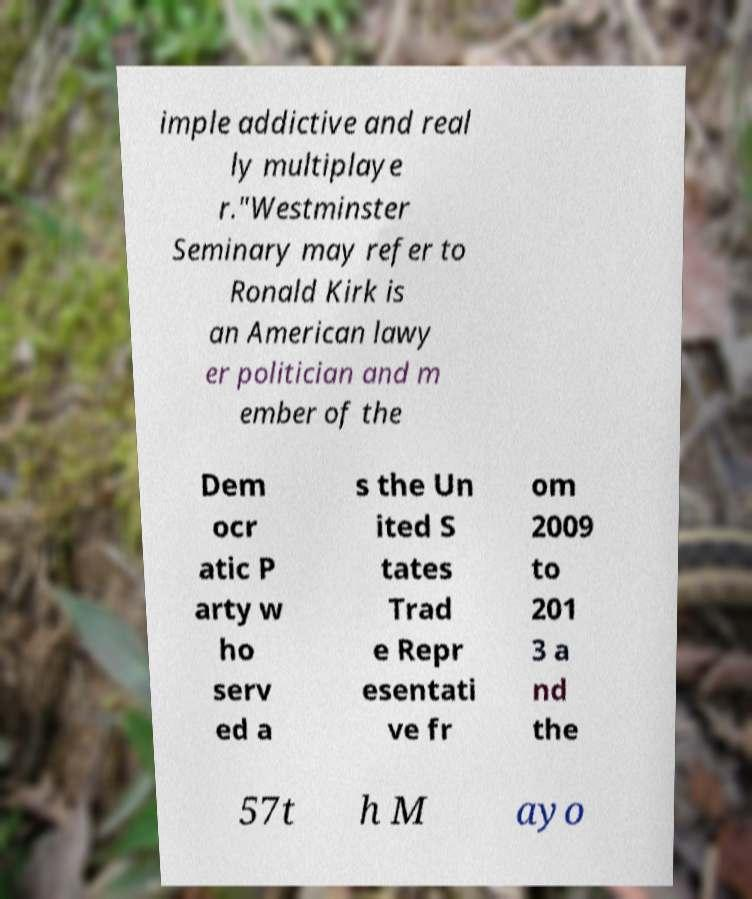Could you extract and type out the text from this image? imple addictive and real ly multiplaye r."Westminster Seminary may refer to Ronald Kirk is an American lawy er politician and m ember of the Dem ocr atic P arty w ho serv ed a s the Un ited S tates Trad e Repr esentati ve fr om 2009 to 201 3 a nd the 57t h M ayo 